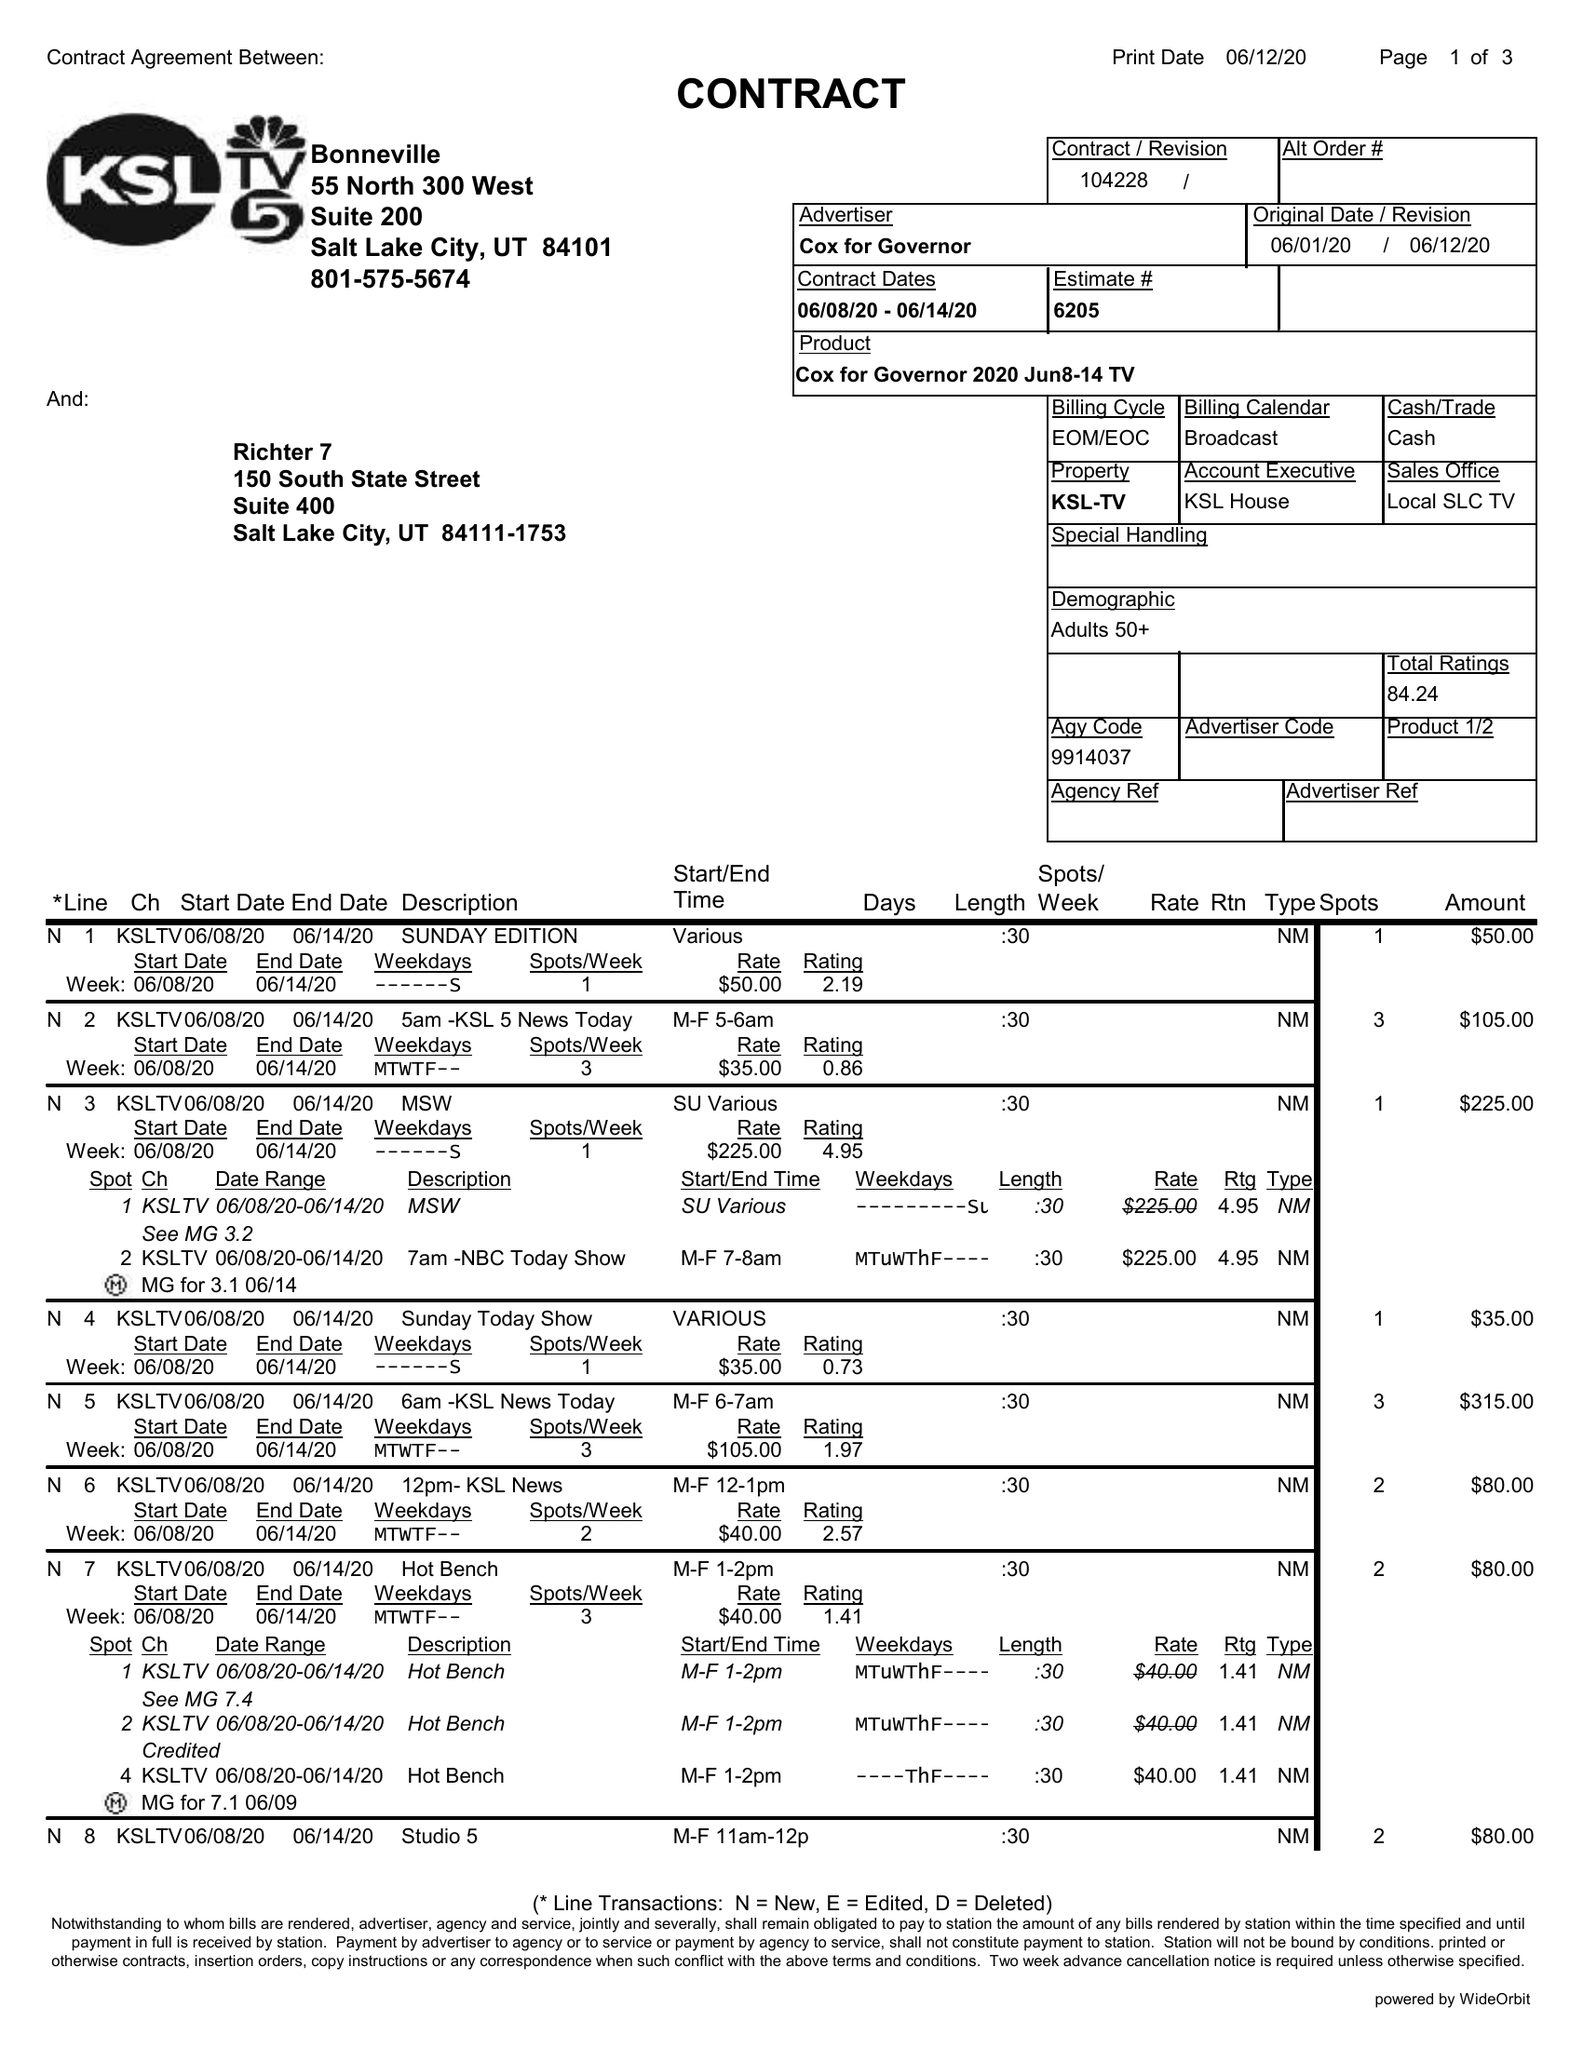What is the value for the flight_to?
Answer the question using a single word or phrase. 06/14/20 